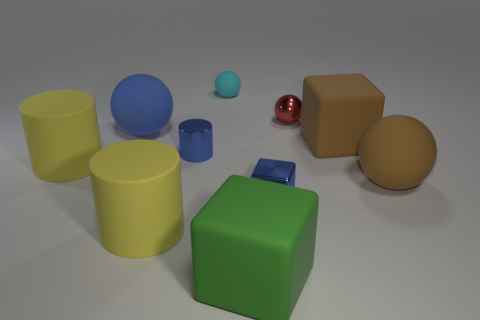Subtract 1 spheres. How many spheres are left? 3 Subtract all cubes. How many objects are left? 7 Subtract 0 yellow blocks. How many objects are left? 10 Subtract all red balls. Subtract all tiny blue cubes. How many objects are left? 8 Add 9 tiny cylinders. How many tiny cylinders are left? 10 Add 7 metal cylinders. How many metal cylinders exist? 8 